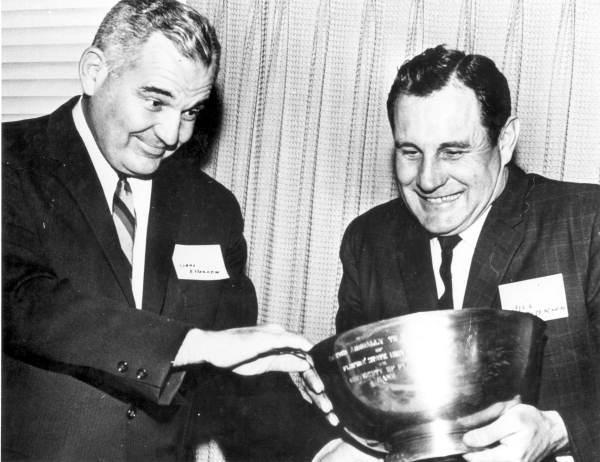How many people are in the photo?
Give a very brief answer. 2. How many orange cups are on the table?
Give a very brief answer. 0. 